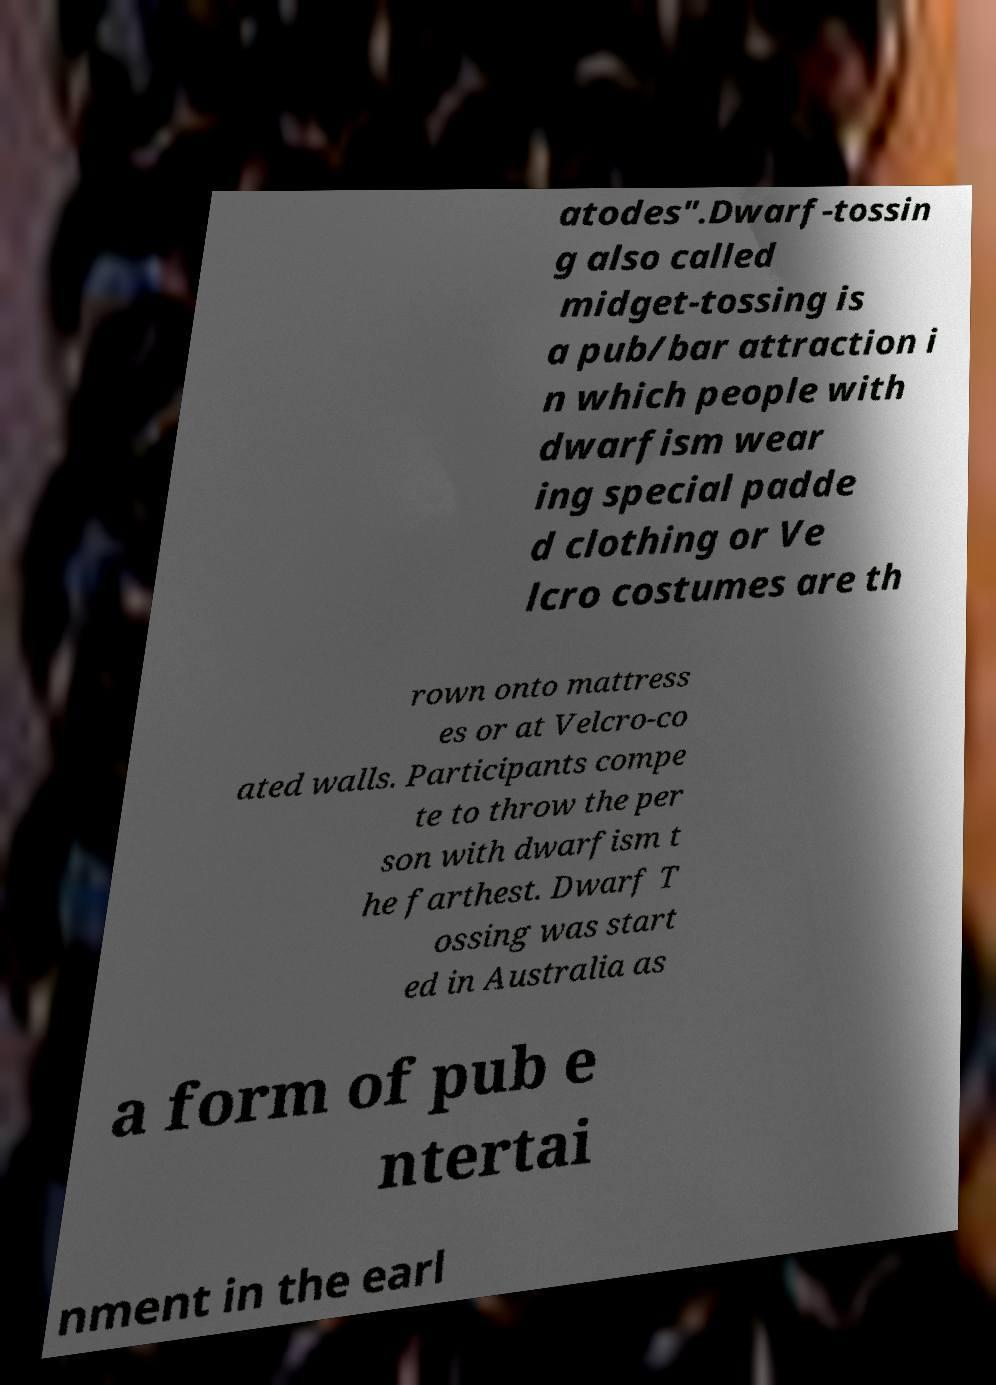There's text embedded in this image that I need extracted. Can you transcribe it verbatim? atodes".Dwarf-tossin g also called midget-tossing is a pub/bar attraction i n which people with dwarfism wear ing special padde d clothing or Ve lcro costumes are th rown onto mattress es or at Velcro-co ated walls. Participants compe te to throw the per son with dwarfism t he farthest. Dwarf T ossing was start ed in Australia as a form of pub e ntertai nment in the earl 